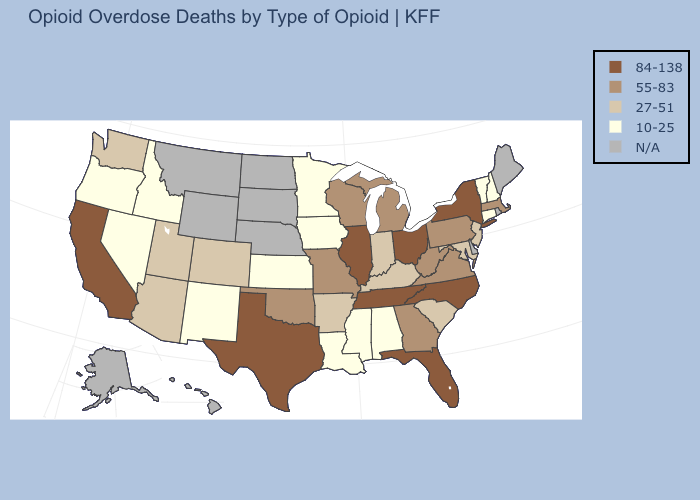Does Alabama have the highest value in the USA?
Answer briefly. No. Which states have the highest value in the USA?
Quick response, please. California, Florida, Illinois, New York, North Carolina, Ohio, Tennessee, Texas. What is the lowest value in the West?
Quick response, please. 10-25. Which states have the highest value in the USA?
Write a very short answer. California, Florida, Illinois, New York, North Carolina, Ohio, Tennessee, Texas. What is the lowest value in the USA?
Keep it brief. 10-25. Does the first symbol in the legend represent the smallest category?
Concise answer only. No. What is the highest value in the USA?
Short answer required. 84-138. Name the states that have a value in the range 10-25?
Short answer required. Alabama, Connecticut, Idaho, Iowa, Kansas, Louisiana, Minnesota, Mississippi, Nevada, New Hampshire, New Mexico, Oregon, Vermont. Name the states that have a value in the range 27-51?
Write a very short answer. Arizona, Arkansas, Colorado, Indiana, Kentucky, Maryland, New Jersey, South Carolina, Utah, Washington. Among the states that border Oklahoma , which have the lowest value?
Quick response, please. Kansas, New Mexico. Does Texas have the highest value in the South?
Answer briefly. Yes. What is the value of Massachusetts?
Keep it brief. 55-83. Does Oklahoma have the highest value in the South?
Answer briefly. No. 